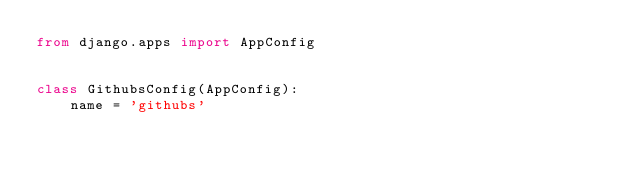<code> <loc_0><loc_0><loc_500><loc_500><_Python_>from django.apps import AppConfig


class GithubsConfig(AppConfig):
    name = 'githubs'
</code> 